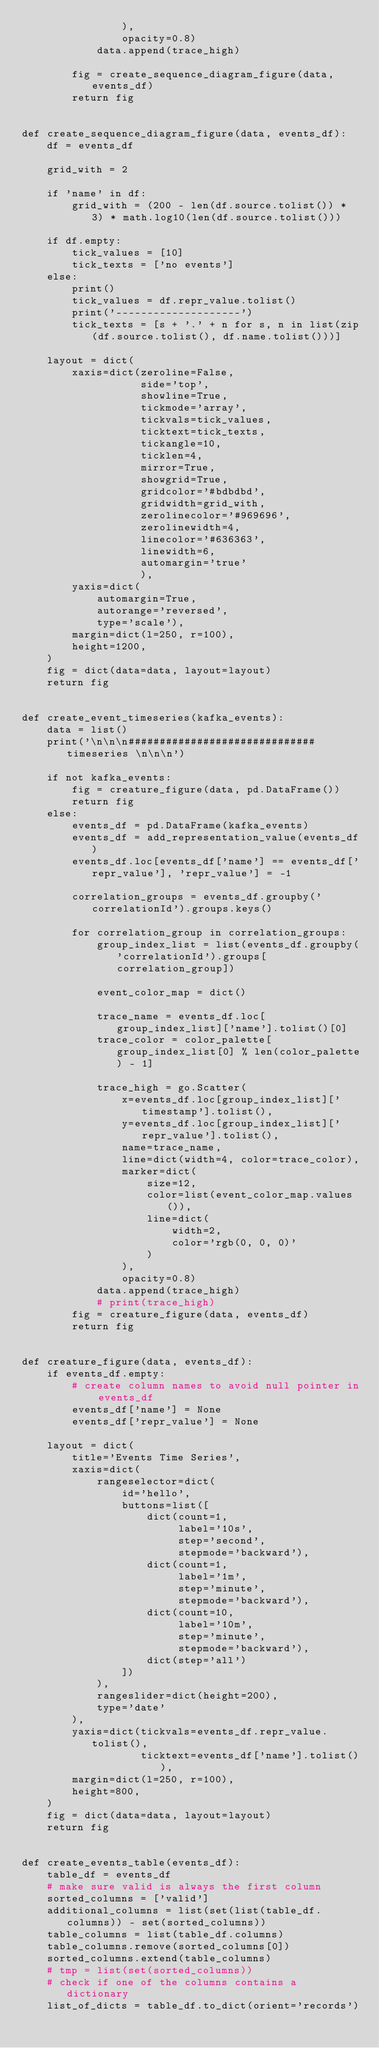Convert code to text. <code><loc_0><loc_0><loc_500><loc_500><_Python_>                ),
                opacity=0.8)
            data.append(trace_high)

        fig = create_sequence_diagram_figure(data, events_df)
        return fig


def create_sequence_diagram_figure(data, events_df):
    df = events_df

    grid_with = 2

    if 'name' in df:
        grid_with = (200 - len(df.source.tolist()) * 3) * math.log10(len(df.source.tolist()))

    if df.empty:
        tick_values = [10]
        tick_texts = ['no events']
    else:
        print()
        tick_values = df.repr_value.tolist()
        print('--------------------')
        tick_texts = [s + '.' + n for s, n in list(zip(df.source.tolist(), df.name.tolist()))]

    layout = dict(
        xaxis=dict(zeroline=False,
                   side='top',
                   showline=True,
                   tickmode='array',
                   tickvals=tick_values,
                   ticktext=tick_texts,
                   tickangle=10,
                   ticklen=4,
                   mirror=True,
                   showgrid=True,
                   gridcolor='#bdbdbd',
                   gridwidth=grid_with,
                   zerolinecolor='#969696',
                   zerolinewidth=4,
                   linecolor='#636363',
                   linewidth=6,
                   automargin='true'
                   ),
        yaxis=dict(
            automargin=True,
            autorange='reversed',
            type='scale'),
        margin=dict(l=250, r=100),
        height=1200,
    )
    fig = dict(data=data, layout=layout)
    return fig


def create_event_timeseries(kafka_events):
    data = list()
    print('\n\n\n############################## timeseries \n\n\n')

    if not kafka_events:
        fig = creature_figure(data, pd.DataFrame())
        return fig
    else:
        events_df = pd.DataFrame(kafka_events)
        events_df = add_representation_value(events_df)
        events_df.loc[events_df['name'] == events_df['repr_value'], 'repr_value'] = -1

        correlation_groups = events_df.groupby('correlationId').groups.keys()

        for correlation_group in correlation_groups:
            group_index_list = list(events_df.groupby('correlationId').groups[correlation_group])

            event_color_map = dict()

            trace_name = events_df.loc[group_index_list]['name'].tolist()[0]
            trace_color = color_palette[group_index_list[0] % len(color_palette) - 1]

            trace_high = go.Scatter(
                x=events_df.loc[group_index_list]['timestamp'].tolist(),
                y=events_df.loc[group_index_list]['repr_value'].tolist(),
                name=trace_name,
                line=dict(width=4, color=trace_color),
                marker=dict(
                    size=12,
                    color=list(event_color_map.values()),
                    line=dict(
                        width=2,
                        color='rgb(0, 0, 0)'
                    )
                ),
                opacity=0.8)
            data.append(trace_high)
            # print(trace_high)
        fig = creature_figure(data, events_df)
        return fig


def creature_figure(data, events_df):
    if events_df.empty:
        # create column names to avoid null pointer in events_df
        events_df['name'] = None
        events_df['repr_value'] = None

    layout = dict(
        title='Events Time Series',
        xaxis=dict(
            rangeselector=dict(
                id='hello',
                buttons=list([
                    dict(count=1,
                         label='10s',
                         step='second',
                         stepmode='backward'),
                    dict(count=1,
                         label='1m',
                         step='minute',
                         stepmode='backward'),
                    dict(count=10,
                         label='10m',
                         step='minute',
                         stepmode='backward'),
                    dict(step='all')
                ])
            ),
            rangeslider=dict(height=200),
            type='date'
        ),
        yaxis=dict(tickvals=events_df.repr_value.tolist(),
                   ticktext=events_df['name'].tolist()),
        margin=dict(l=250, r=100),
        height=800,
    )
    fig = dict(data=data, layout=layout)
    return fig


def create_events_table(events_df):
    table_df = events_df
    # make sure valid is always the first column
    sorted_columns = ['valid']
    additional_columns = list(set(list(table_df.columns)) - set(sorted_columns))
    table_columns = list(table_df.columns)
    table_columns.remove(sorted_columns[0])
    sorted_columns.extend(table_columns)
    # tmp = list(set(sorted_columns))
    # check if one of the columns contains a dictionary
    list_of_dicts = table_df.to_dict(orient='records')</code> 